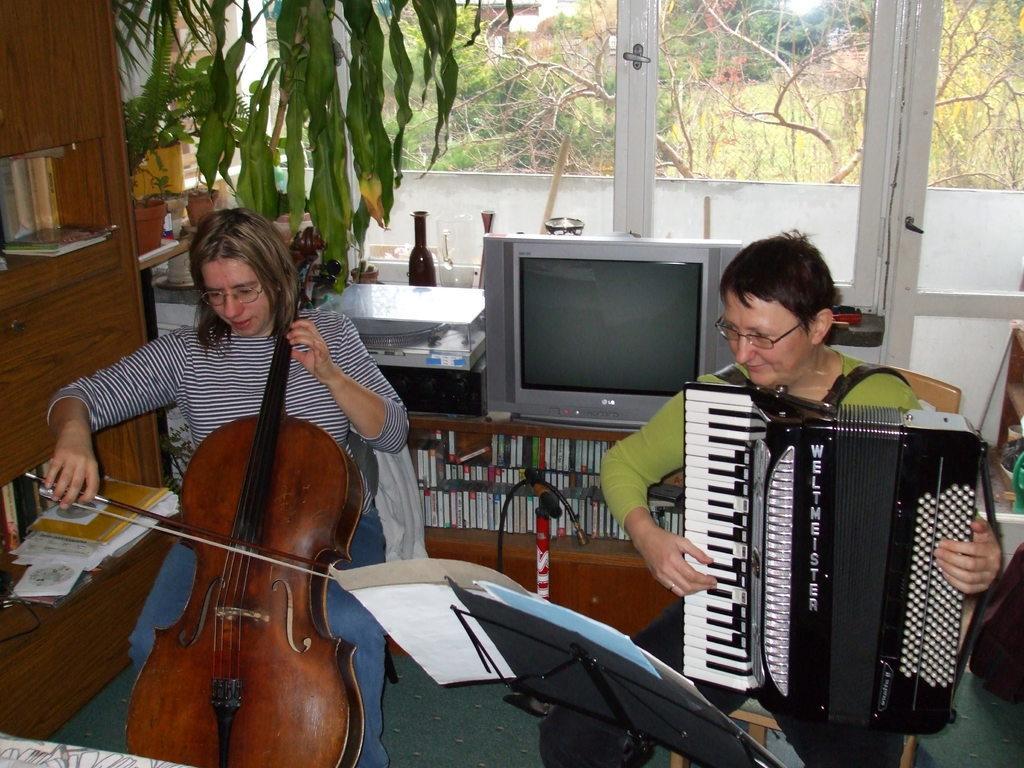Could you give a brief overview of what you see in this image? In this image i can see 2 women sitting on chairs and holding musical instruments in their hands. I can see a paper stand in front of them. In the background i can see a television screen and few cassettes in the desk, a plant. a bottle, a glass window through which i can see few trees, few buildings and the sky. 